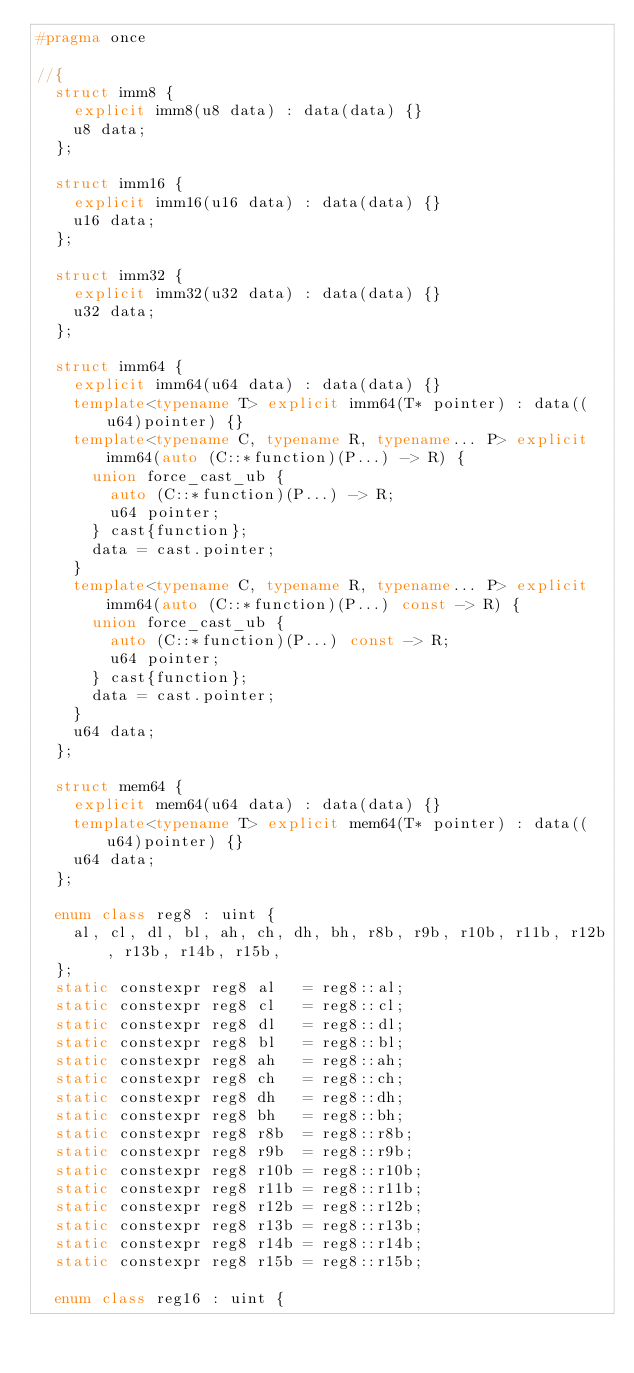<code> <loc_0><loc_0><loc_500><loc_500><_C++_>#pragma once

//{
  struct imm8 {
    explicit imm8(u8 data) : data(data) {}
    u8 data;
  };

  struct imm16 {
    explicit imm16(u16 data) : data(data) {}
    u16 data;
  };

  struct imm32 {
    explicit imm32(u32 data) : data(data) {}
    u32 data;
  };

  struct imm64 {
    explicit imm64(u64 data) : data(data) {}
    template<typename T> explicit imm64(T* pointer) : data((u64)pointer) {}
    template<typename C, typename R, typename... P> explicit imm64(auto (C::*function)(P...) -> R) {
      union force_cast_ub {
        auto (C::*function)(P...) -> R;
        u64 pointer;
      } cast{function};
      data = cast.pointer;
    }
    template<typename C, typename R, typename... P> explicit imm64(auto (C::*function)(P...) const -> R) {
      union force_cast_ub {
        auto (C::*function)(P...) const -> R;
        u64 pointer;
      } cast{function};
      data = cast.pointer;
    }
    u64 data;
  };

  struct mem64 {
    explicit mem64(u64 data) : data(data) {}
    template<typename T> explicit mem64(T* pointer) : data((u64)pointer) {}
    u64 data;
  };

  enum class reg8 : uint {
    al, cl, dl, bl, ah, ch, dh, bh, r8b, r9b, r10b, r11b, r12b, r13b, r14b, r15b,
  };
  static constexpr reg8 al   = reg8::al;
  static constexpr reg8 cl   = reg8::cl;
  static constexpr reg8 dl   = reg8::dl;
  static constexpr reg8 bl   = reg8::bl;
  static constexpr reg8 ah   = reg8::ah;
  static constexpr reg8 ch   = reg8::ch;
  static constexpr reg8 dh   = reg8::dh;
  static constexpr reg8 bh   = reg8::bh;
  static constexpr reg8 r8b  = reg8::r8b;
  static constexpr reg8 r9b  = reg8::r9b;
  static constexpr reg8 r10b = reg8::r10b;
  static constexpr reg8 r11b = reg8::r11b;
  static constexpr reg8 r12b = reg8::r12b;
  static constexpr reg8 r13b = reg8::r13b;
  static constexpr reg8 r14b = reg8::r14b;
  static constexpr reg8 r15b = reg8::r15b;

  enum class reg16 : uint {</code> 